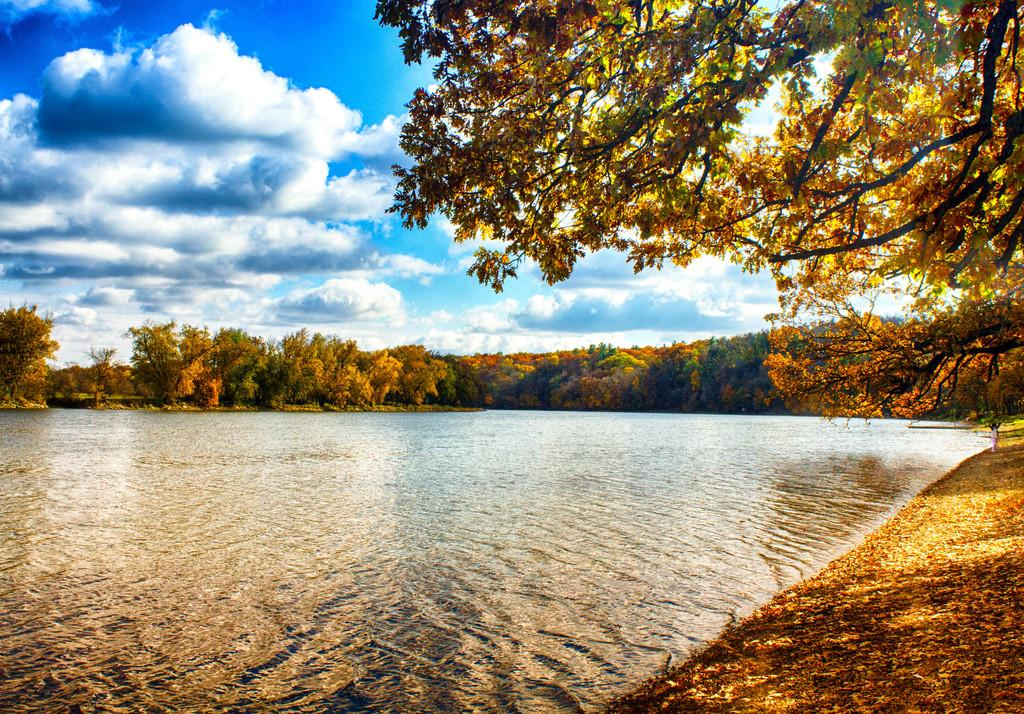What type of vegetation can be seen in the image? There are trees in the image. What natural element is visible besides the trees? There is water visible in the image. What can be seen in the background of the image? The sky is visible in the background of the image. What type of pig can be seen in the image? There is no pig present in the image. Is there a group of people visible in the image? There is no group of people mentioned in the provided facts, so we cannot determine if there is a group present in the image. 